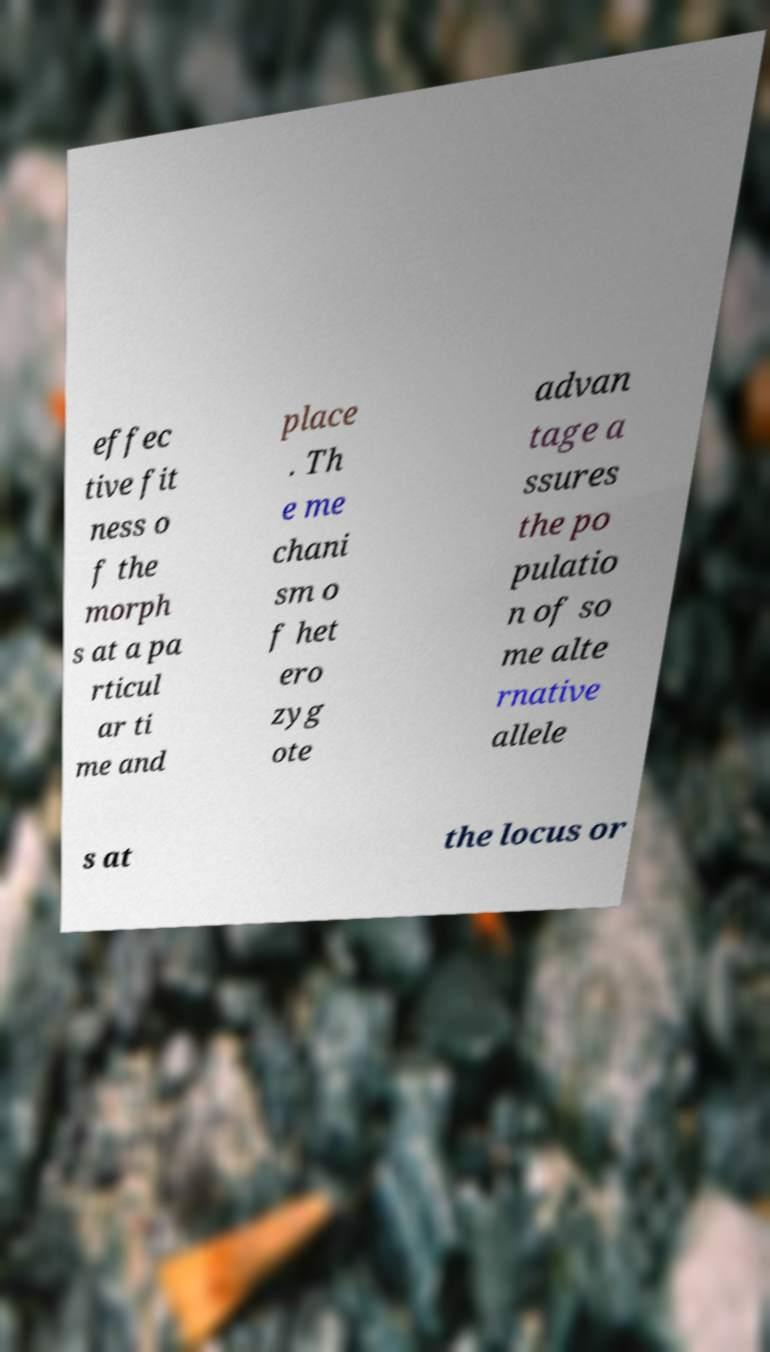I need the written content from this picture converted into text. Can you do that? effec tive fit ness o f the morph s at a pa rticul ar ti me and place . Th e me chani sm o f het ero zyg ote advan tage a ssures the po pulatio n of so me alte rnative allele s at the locus or 